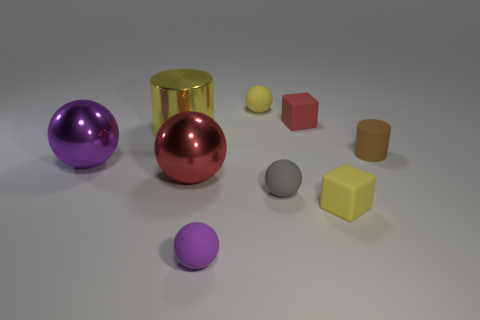Subtract all red balls. How many balls are left? 4 Subtract all large red spheres. How many spheres are left? 4 Subtract all blue spheres. Subtract all gray cubes. How many spheres are left? 5 Add 1 small blocks. How many objects exist? 10 Subtract all cubes. How many objects are left? 7 Subtract all red objects. Subtract all tiny rubber balls. How many objects are left? 4 Add 4 small gray objects. How many small gray objects are left? 5 Add 7 big red metal spheres. How many big red metal spheres exist? 8 Subtract 0 green cylinders. How many objects are left? 9 